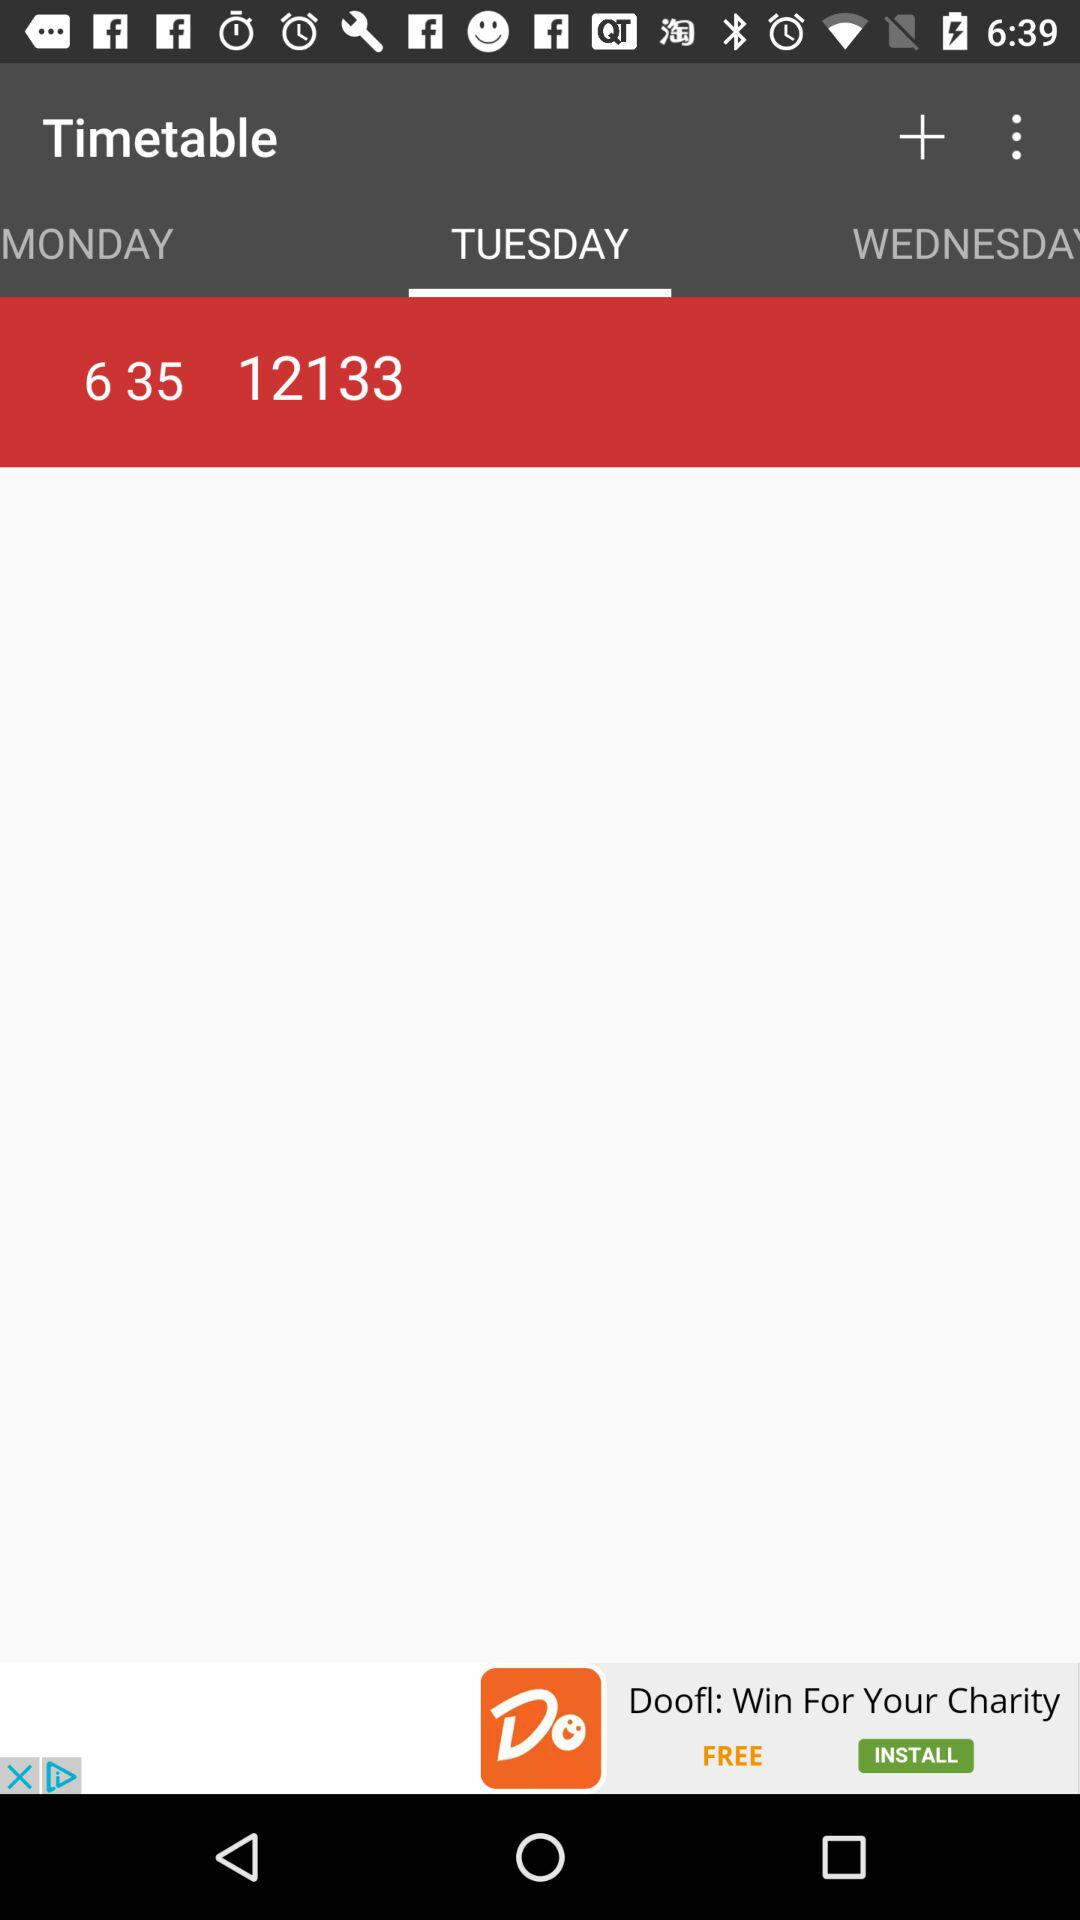What is the selected tab? The selected tab is "TUESDAY". 